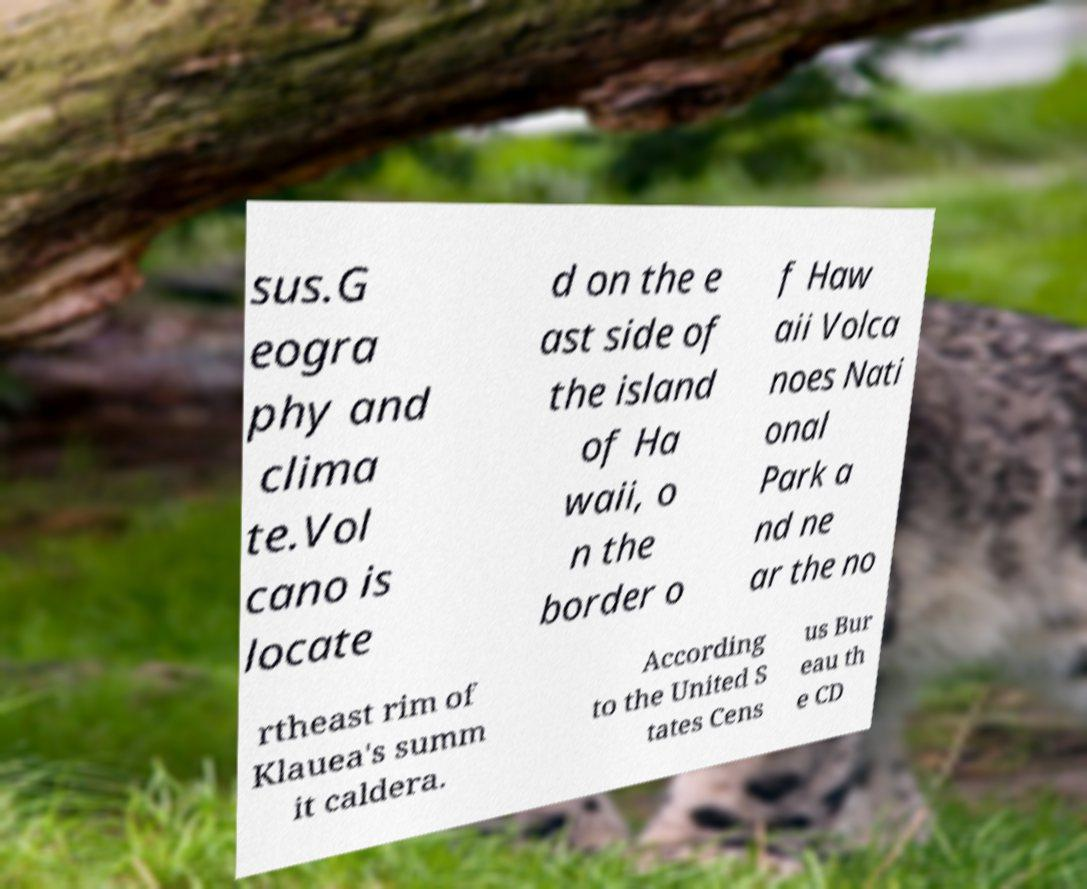Could you assist in decoding the text presented in this image and type it out clearly? sus.G eogra phy and clima te.Vol cano is locate d on the e ast side of the island of Ha waii, o n the border o f Haw aii Volca noes Nati onal Park a nd ne ar the no rtheast rim of Klauea's summ it caldera. According to the United S tates Cens us Bur eau th e CD 